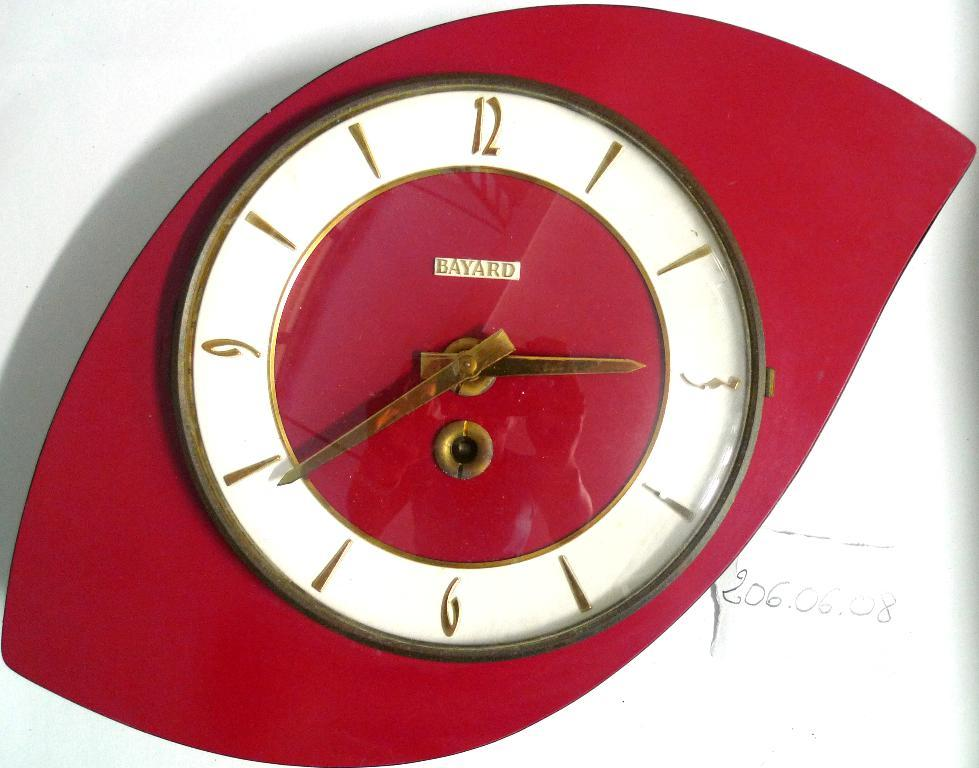Provide a one-sentence caption for the provided image. A red Bayard clock in the art deco style is mounted on a white wall. 